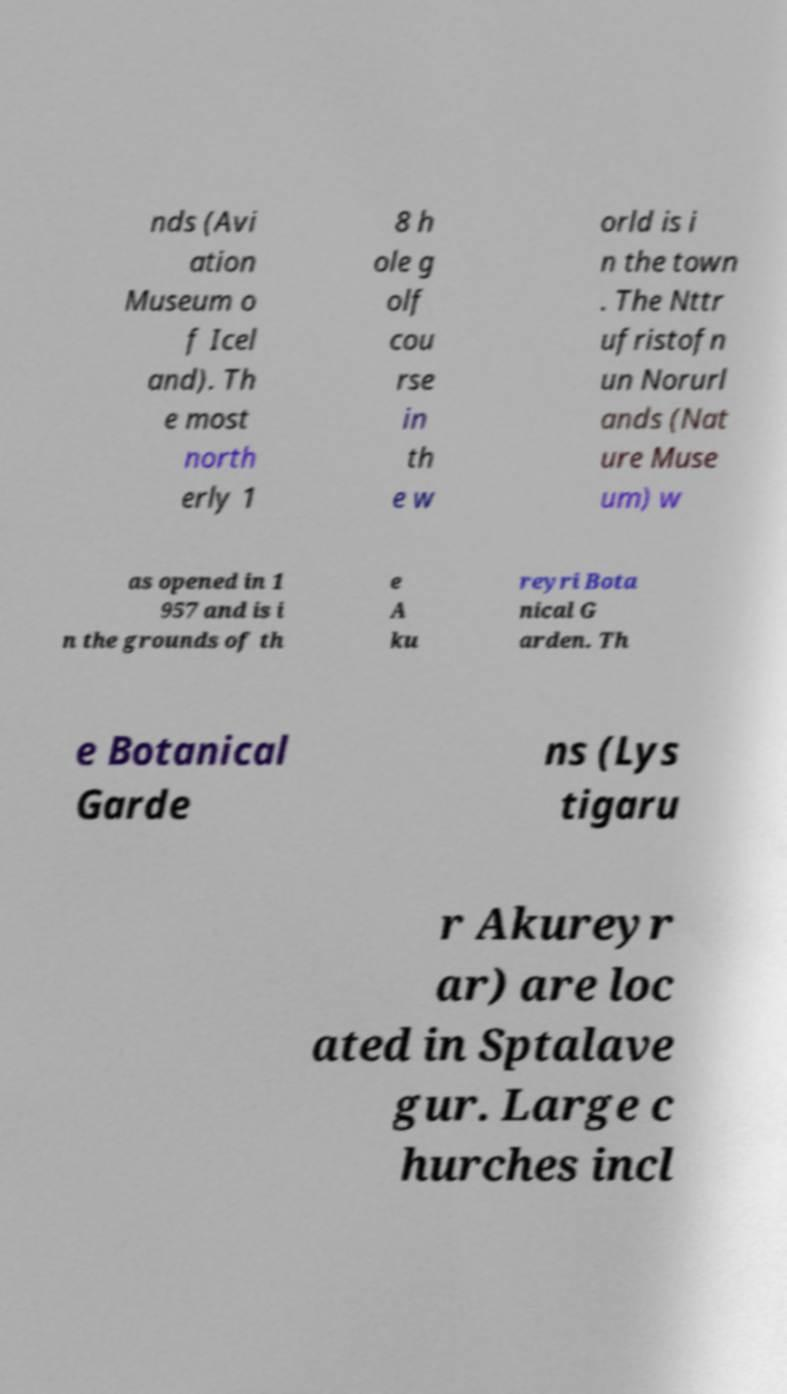For documentation purposes, I need the text within this image transcribed. Could you provide that? nds (Avi ation Museum o f Icel and). Th e most north erly 1 8 h ole g olf cou rse in th e w orld is i n the town . The Nttr ufristofn un Norurl ands (Nat ure Muse um) w as opened in 1 957 and is i n the grounds of th e A ku reyri Bota nical G arden. Th e Botanical Garde ns (Lys tigaru r Akureyr ar) are loc ated in Sptalave gur. Large c hurches incl 